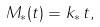<formula> <loc_0><loc_0><loc_500><loc_500>M _ { * } ( t ) = k _ { * } \, t ,</formula> 